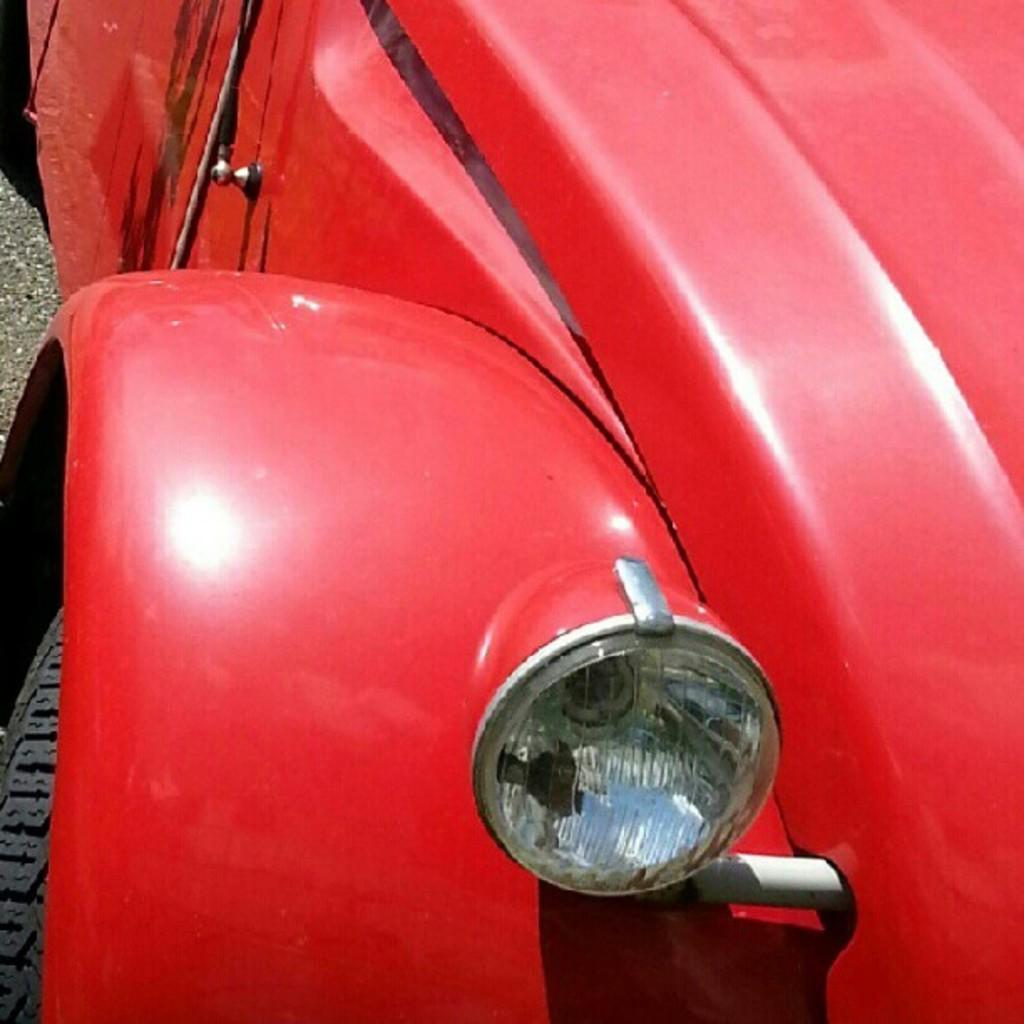In one or two sentences, can you explain what this image depicts? In this picture we can observe a red color car. On the right side there is a bonnet. We can observe a headlight. On the left side there is a tire. The car is on the road. 